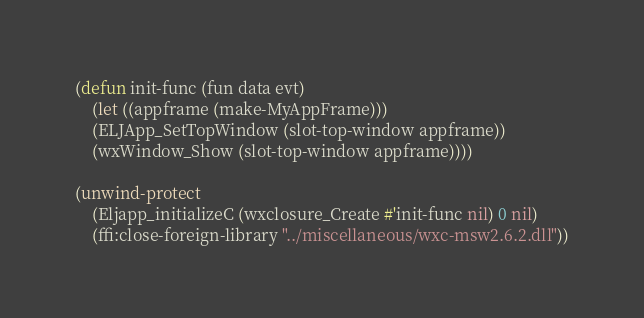<code> <loc_0><loc_0><loc_500><loc_500><_Lisp_>(defun init-func (fun data evt)
    (let ((appframe (make-MyAppFrame)))
    (ELJApp_SetTopWindow (slot-top-window appframe))
    (wxWindow_Show (slot-top-window appframe))))

(unwind-protect
    (Eljapp_initializeC (wxclosure_Create #'init-func nil) 0 nil)
    (ffi:close-foreign-library "../miscellaneous/wxc-msw2.6.2.dll"))
</code> 